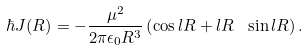<formula> <loc_0><loc_0><loc_500><loc_500>\hbar { J } ( R ) = - \frac { \mu ^ { 2 } } { 2 \pi \epsilon _ { 0 } R ^ { 3 } } \left ( \cos l R + l R \ \sin l R \right ) .</formula> 